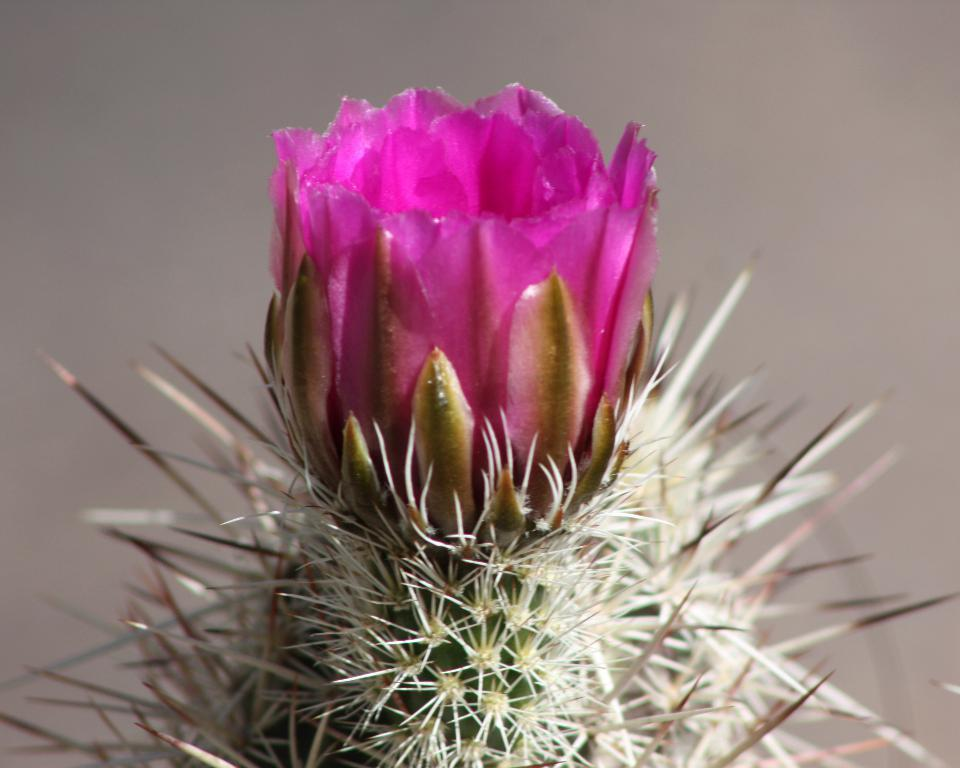What type of plant is present in the image? There is a cactus in the image. Are there any additional features on the cactus? Yes, there is a cactus flower in the image. What type of grip can be seen on the cactus in the image? There is no grip present on the cactus in the image; it is a plant with a natural surface. 